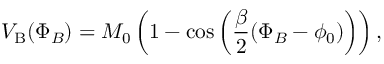Convert formula to latex. <formula><loc_0><loc_0><loc_500><loc_500>V _ { B } ( \Phi _ { B } ) = M _ { 0 } \left ( 1 - \cos \left ( \frac { \beta } { 2 } ( \Phi _ { B } - \phi _ { 0 } ) \right ) \right ) ,</formula> 